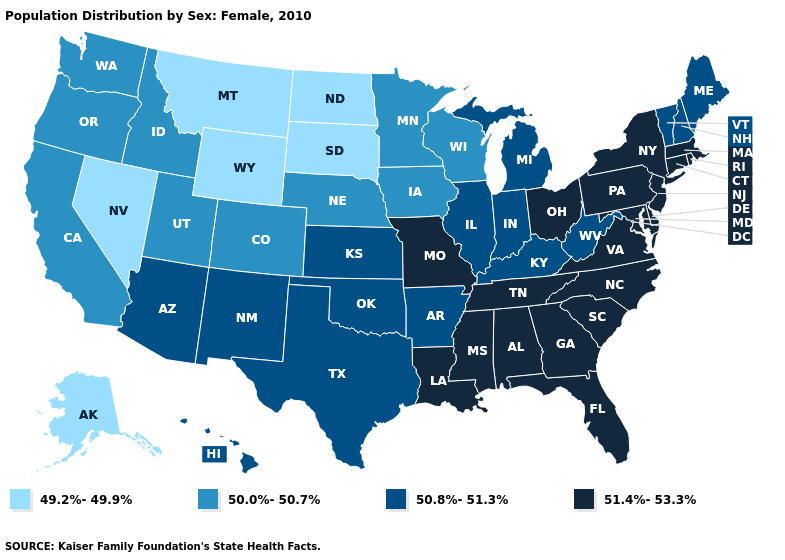Does Nevada have the same value as South Dakota?
Give a very brief answer. Yes. Among the states that border Tennessee , does Kentucky have the lowest value?
Concise answer only. Yes. Name the states that have a value in the range 49.2%-49.9%?
Keep it brief. Alaska, Montana, Nevada, North Dakota, South Dakota, Wyoming. Name the states that have a value in the range 49.2%-49.9%?
Keep it brief. Alaska, Montana, Nevada, North Dakota, South Dakota, Wyoming. What is the value of Kentucky?
Concise answer only. 50.8%-51.3%. Which states hav the highest value in the MidWest?
Concise answer only. Missouri, Ohio. Which states have the highest value in the USA?
Give a very brief answer. Alabama, Connecticut, Delaware, Florida, Georgia, Louisiana, Maryland, Massachusetts, Mississippi, Missouri, New Jersey, New York, North Carolina, Ohio, Pennsylvania, Rhode Island, South Carolina, Tennessee, Virginia. Does Delaware have the highest value in the USA?
Keep it brief. Yes. Which states have the lowest value in the South?
Give a very brief answer. Arkansas, Kentucky, Oklahoma, Texas, West Virginia. What is the lowest value in the MidWest?
Short answer required. 49.2%-49.9%. What is the highest value in states that border Ohio?
Give a very brief answer. 51.4%-53.3%. What is the value of North Dakota?
Concise answer only. 49.2%-49.9%. Which states hav the highest value in the West?
Answer briefly. Arizona, Hawaii, New Mexico. Does Massachusetts have the highest value in the USA?
Concise answer only. Yes. 